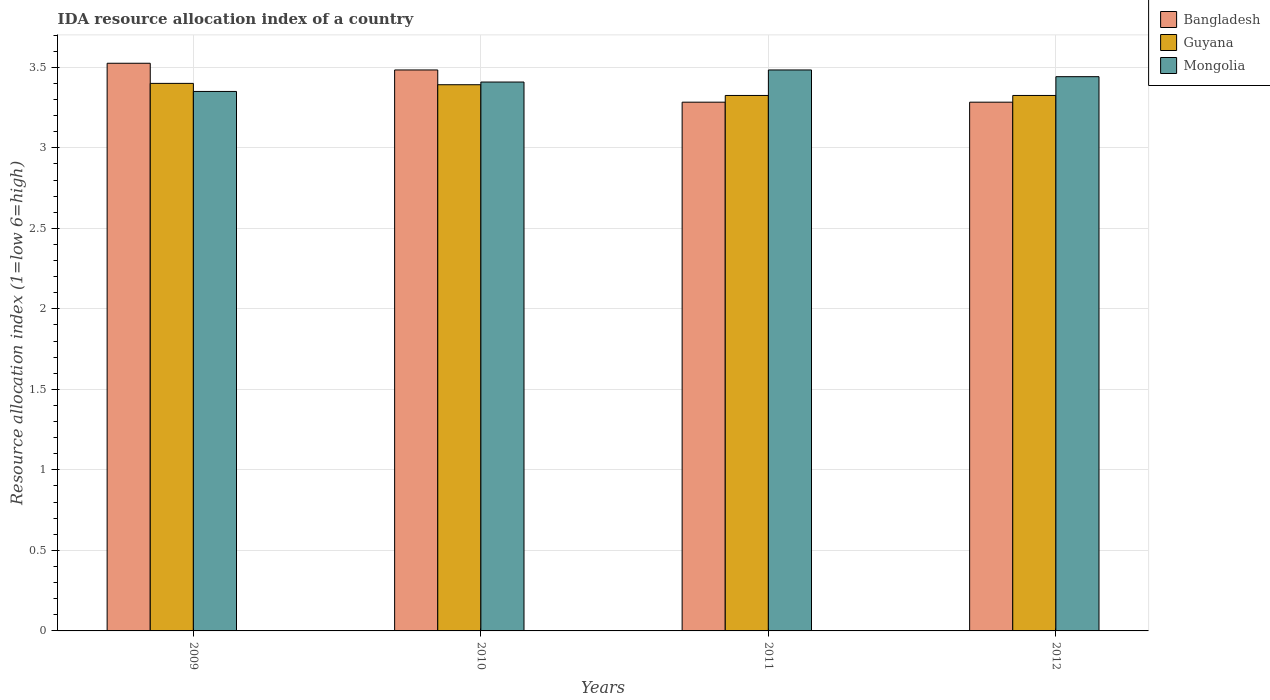Are the number of bars on each tick of the X-axis equal?
Your answer should be very brief. Yes. What is the IDA resource allocation index in Bangladesh in 2009?
Offer a very short reply. 3.52. Across all years, what is the maximum IDA resource allocation index in Bangladesh?
Offer a very short reply. 3.52. Across all years, what is the minimum IDA resource allocation index in Guyana?
Provide a succinct answer. 3.33. What is the total IDA resource allocation index in Bangladesh in the graph?
Keep it short and to the point. 13.57. What is the difference between the IDA resource allocation index in Bangladesh in 2009 and that in 2011?
Make the answer very short. 0.24. What is the difference between the IDA resource allocation index in Guyana in 2011 and the IDA resource allocation index in Bangladesh in 2009?
Make the answer very short. -0.2. What is the average IDA resource allocation index in Mongolia per year?
Keep it short and to the point. 3.42. In the year 2009, what is the difference between the IDA resource allocation index in Guyana and IDA resource allocation index in Mongolia?
Your answer should be very brief. 0.05. What is the ratio of the IDA resource allocation index in Mongolia in 2009 to that in 2012?
Your answer should be very brief. 0.97. Is the difference between the IDA resource allocation index in Guyana in 2009 and 2012 greater than the difference between the IDA resource allocation index in Mongolia in 2009 and 2012?
Your answer should be very brief. Yes. What is the difference between the highest and the second highest IDA resource allocation index in Guyana?
Your answer should be very brief. 0.01. What is the difference between the highest and the lowest IDA resource allocation index in Mongolia?
Offer a very short reply. 0.13. Is the sum of the IDA resource allocation index in Bangladesh in 2010 and 2011 greater than the maximum IDA resource allocation index in Mongolia across all years?
Ensure brevity in your answer.  Yes. What does the 3rd bar from the left in 2010 represents?
Offer a terse response. Mongolia. What does the 3rd bar from the right in 2010 represents?
Offer a very short reply. Bangladesh. How many bars are there?
Give a very brief answer. 12. How many years are there in the graph?
Give a very brief answer. 4. What is the difference between two consecutive major ticks on the Y-axis?
Your answer should be very brief. 0.5. Are the values on the major ticks of Y-axis written in scientific E-notation?
Ensure brevity in your answer.  No. Does the graph contain any zero values?
Keep it short and to the point. No. How many legend labels are there?
Offer a terse response. 3. How are the legend labels stacked?
Make the answer very short. Vertical. What is the title of the graph?
Your response must be concise. IDA resource allocation index of a country. Does "Low income" appear as one of the legend labels in the graph?
Provide a succinct answer. No. What is the label or title of the X-axis?
Your answer should be compact. Years. What is the label or title of the Y-axis?
Give a very brief answer. Resource allocation index (1=low 6=high). What is the Resource allocation index (1=low 6=high) of Bangladesh in 2009?
Provide a succinct answer. 3.52. What is the Resource allocation index (1=low 6=high) of Guyana in 2009?
Provide a succinct answer. 3.4. What is the Resource allocation index (1=low 6=high) in Mongolia in 2009?
Give a very brief answer. 3.35. What is the Resource allocation index (1=low 6=high) of Bangladesh in 2010?
Keep it short and to the point. 3.48. What is the Resource allocation index (1=low 6=high) in Guyana in 2010?
Offer a very short reply. 3.39. What is the Resource allocation index (1=low 6=high) of Mongolia in 2010?
Offer a terse response. 3.41. What is the Resource allocation index (1=low 6=high) in Bangladesh in 2011?
Offer a terse response. 3.28. What is the Resource allocation index (1=low 6=high) of Guyana in 2011?
Provide a short and direct response. 3.33. What is the Resource allocation index (1=low 6=high) in Mongolia in 2011?
Make the answer very short. 3.48. What is the Resource allocation index (1=low 6=high) of Bangladesh in 2012?
Offer a terse response. 3.28. What is the Resource allocation index (1=low 6=high) in Guyana in 2012?
Provide a short and direct response. 3.33. What is the Resource allocation index (1=low 6=high) of Mongolia in 2012?
Ensure brevity in your answer.  3.44. Across all years, what is the maximum Resource allocation index (1=low 6=high) in Bangladesh?
Ensure brevity in your answer.  3.52. Across all years, what is the maximum Resource allocation index (1=low 6=high) in Mongolia?
Keep it short and to the point. 3.48. Across all years, what is the minimum Resource allocation index (1=low 6=high) in Bangladesh?
Ensure brevity in your answer.  3.28. Across all years, what is the minimum Resource allocation index (1=low 6=high) of Guyana?
Your answer should be very brief. 3.33. Across all years, what is the minimum Resource allocation index (1=low 6=high) in Mongolia?
Ensure brevity in your answer.  3.35. What is the total Resource allocation index (1=low 6=high) in Bangladesh in the graph?
Your response must be concise. 13.57. What is the total Resource allocation index (1=low 6=high) in Guyana in the graph?
Offer a terse response. 13.44. What is the total Resource allocation index (1=low 6=high) in Mongolia in the graph?
Give a very brief answer. 13.68. What is the difference between the Resource allocation index (1=low 6=high) in Bangladesh in 2009 and that in 2010?
Make the answer very short. 0.04. What is the difference between the Resource allocation index (1=low 6=high) in Guyana in 2009 and that in 2010?
Offer a very short reply. 0.01. What is the difference between the Resource allocation index (1=low 6=high) of Mongolia in 2009 and that in 2010?
Keep it short and to the point. -0.06. What is the difference between the Resource allocation index (1=low 6=high) in Bangladesh in 2009 and that in 2011?
Give a very brief answer. 0.24. What is the difference between the Resource allocation index (1=low 6=high) of Guyana in 2009 and that in 2011?
Your answer should be very brief. 0.07. What is the difference between the Resource allocation index (1=low 6=high) in Mongolia in 2009 and that in 2011?
Provide a short and direct response. -0.13. What is the difference between the Resource allocation index (1=low 6=high) in Bangladesh in 2009 and that in 2012?
Give a very brief answer. 0.24. What is the difference between the Resource allocation index (1=low 6=high) of Guyana in 2009 and that in 2012?
Provide a succinct answer. 0.07. What is the difference between the Resource allocation index (1=low 6=high) of Mongolia in 2009 and that in 2012?
Your response must be concise. -0.09. What is the difference between the Resource allocation index (1=low 6=high) in Bangladesh in 2010 and that in 2011?
Your answer should be very brief. 0.2. What is the difference between the Resource allocation index (1=low 6=high) in Guyana in 2010 and that in 2011?
Provide a short and direct response. 0.07. What is the difference between the Resource allocation index (1=low 6=high) of Mongolia in 2010 and that in 2011?
Provide a short and direct response. -0.07. What is the difference between the Resource allocation index (1=low 6=high) of Guyana in 2010 and that in 2012?
Your answer should be compact. 0.07. What is the difference between the Resource allocation index (1=low 6=high) in Mongolia in 2010 and that in 2012?
Keep it short and to the point. -0.03. What is the difference between the Resource allocation index (1=low 6=high) in Bangladesh in 2011 and that in 2012?
Make the answer very short. 0. What is the difference between the Resource allocation index (1=low 6=high) of Guyana in 2011 and that in 2012?
Keep it short and to the point. 0. What is the difference between the Resource allocation index (1=low 6=high) of Mongolia in 2011 and that in 2012?
Ensure brevity in your answer.  0.04. What is the difference between the Resource allocation index (1=low 6=high) in Bangladesh in 2009 and the Resource allocation index (1=low 6=high) in Guyana in 2010?
Make the answer very short. 0.13. What is the difference between the Resource allocation index (1=low 6=high) of Bangladesh in 2009 and the Resource allocation index (1=low 6=high) of Mongolia in 2010?
Ensure brevity in your answer.  0.12. What is the difference between the Resource allocation index (1=low 6=high) in Guyana in 2009 and the Resource allocation index (1=low 6=high) in Mongolia in 2010?
Your answer should be compact. -0.01. What is the difference between the Resource allocation index (1=low 6=high) in Bangladesh in 2009 and the Resource allocation index (1=low 6=high) in Guyana in 2011?
Your response must be concise. 0.2. What is the difference between the Resource allocation index (1=low 6=high) in Bangladesh in 2009 and the Resource allocation index (1=low 6=high) in Mongolia in 2011?
Offer a very short reply. 0.04. What is the difference between the Resource allocation index (1=low 6=high) in Guyana in 2009 and the Resource allocation index (1=low 6=high) in Mongolia in 2011?
Give a very brief answer. -0.08. What is the difference between the Resource allocation index (1=low 6=high) of Bangladesh in 2009 and the Resource allocation index (1=low 6=high) of Guyana in 2012?
Provide a succinct answer. 0.2. What is the difference between the Resource allocation index (1=low 6=high) in Bangladesh in 2009 and the Resource allocation index (1=low 6=high) in Mongolia in 2012?
Ensure brevity in your answer.  0.08. What is the difference between the Resource allocation index (1=low 6=high) in Guyana in 2009 and the Resource allocation index (1=low 6=high) in Mongolia in 2012?
Provide a succinct answer. -0.04. What is the difference between the Resource allocation index (1=low 6=high) in Bangladesh in 2010 and the Resource allocation index (1=low 6=high) in Guyana in 2011?
Offer a terse response. 0.16. What is the difference between the Resource allocation index (1=low 6=high) in Bangladesh in 2010 and the Resource allocation index (1=low 6=high) in Mongolia in 2011?
Offer a very short reply. 0. What is the difference between the Resource allocation index (1=low 6=high) of Guyana in 2010 and the Resource allocation index (1=low 6=high) of Mongolia in 2011?
Your answer should be compact. -0.09. What is the difference between the Resource allocation index (1=low 6=high) in Bangladesh in 2010 and the Resource allocation index (1=low 6=high) in Guyana in 2012?
Your answer should be very brief. 0.16. What is the difference between the Resource allocation index (1=low 6=high) in Bangladesh in 2010 and the Resource allocation index (1=low 6=high) in Mongolia in 2012?
Offer a very short reply. 0.04. What is the difference between the Resource allocation index (1=low 6=high) of Bangladesh in 2011 and the Resource allocation index (1=low 6=high) of Guyana in 2012?
Your response must be concise. -0.04. What is the difference between the Resource allocation index (1=low 6=high) in Bangladesh in 2011 and the Resource allocation index (1=low 6=high) in Mongolia in 2012?
Provide a succinct answer. -0.16. What is the difference between the Resource allocation index (1=low 6=high) in Guyana in 2011 and the Resource allocation index (1=low 6=high) in Mongolia in 2012?
Give a very brief answer. -0.12. What is the average Resource allocation index (1=low 6=high) of Bangladesh per year?
Give a very brief answer. 3.39. What is the average Resource allocation index (1=low 6=high) of Guyana per year?
Ensure brevity in your answer.  3.36. What is the average Resource allocation index (1=low 6=high) in Mongolia per year?
Your response must be concise. 3.42. In the year 2009, what is the difference between the Resource allocation index (1=low 6=high) in Bangladesh and Resource allocation index (1=low 6=high) in Guyana?
Provide a short and direct response. 0.12. In the year 2009, what is the difference between the Resource allocation index (1=low 6=high) of Bangladesh and Resource allocation index (1=low 6=high) of Mongolia?
Provide a short and direct response. 0.17. In the year 2009, what is the difference between the Resource allocation index (1=low 6=high) in Guyana and Resource allocation index (1=low 6=high) in Mongolia?
Provide a short and direct response. 0.05. In the year 2010, what is the difference between the Resource allocation index (1=low 6=high) in Bangladesh and Resource allocation index (1=low 6=high) in Guyana?
Your response must be concise. 0.09. In the year 2010, what is the difference between the Resource allocation index (1=low 6=high) in Bangladesh and Resource allocation index (1=low 6=high) in Mongolia?
Your response must be concise. 0.07. In the year 2010, what is the difference between the Resource allocation index (1=low 6=high) in Guyana and Resource allocation index (1=low 6=high) in Mongolia?
Offer a terse response. -0.02. In the year 2011, what is the difference between the Resource allocation index (1=low 6=high) in Bangladesh and Resource allocation index (1=low 6=high) in Guyana?
Your answer should be very brief. -0.04. In the year 2011, what is the difference between the Resource allocation index (1=low 6=high) of Bangladesh and Resource allocation index (1=low 6=high) of Mongolia?
Provide a short and direct response. -0.2. In the year 2011, what is the difference between the Resource allocation index (1=low 6=high) of Guyana and Resource allocation index (1=low 6=high) of Mongolia?
Offer a terse response. -0.16. In the year 2012, what is the difference between the Resource allocation index (1=low 6=high) of Bangladesh and Resource allocation index (1=low 6=high) of Guyana?
Your response must be concise. -0.04. In the year 2012, what is the difference between the Resource allocation index (1=low 6=high) in Bangladesh and Resource allocation index (1=low 6=high) in Mongolia?
Your answer should be compact. -0.16. In the year 2012, what is the difference between the Resource allocation index (1=low 6=high) in Guyana and Resource allocation index (1=low 6=high) in Mongolia?
Make the answer very short. -0.12. What is the ratio of the Resource allocation index (1=low 6=high) of Bangladesh in 2009 to that in 2010?
Ensure brevity in your answer.  1.01. What is the ratio of the Resource allocation index (1=low 6=high) of Guyana in 2009 to that in 2010?
Your answer should be very brief. 1. What is the ratio of the Resource allocation index (1=low 6=high) of Mongolia in 2009 to that in 2010?
Your answer should be compact. 0.98. What is the ratio of the Resource allocation index (1=low 6=high) in Bangladesh in 2009 to that in 2011?
Keep it short and to the point. 1.07. What is the ratio of the Resource allocation index (1=low 6=high) of Guyana in 2009 to that in 2011?
Make the answer very short. 1.02. What is the ratio of the Resource allocation index (1=low 6=high) of Mongolia in 2009 to that in 2011?
Provide a short and direct response. 0.96. What is the ratio of the Resource allocation index (1=low 6=high) of Bangladesh in 2009 to that in 2012?
Ensure brevity in your answer.  1.07. What is the ratio of the Resource allocation index (1=low 6=high) in Guyana in 2009 to that in 2012?
Keep it short and to the point. 1.02. What is the ratio of the Resource allocation index (1=low 6=high) of Mongolia in 2009 to that in 2012?
Offer a terse response. 0.97. What is the ratio of the Resource allocation index (1=low 6=high) in Bangladesh in 2010 to that in 2011?
Keep it short and to the point. 1.06. What is the ratio of the Resource allocation index (1=low 6=high) in Guyana in 2010 to that in 2011?
Offer a terse response. 1.02. What is the ratio of the Resource allocation index (1=low 6=high) in Mongolia in 2010 to that in 2011?
Provide a succinct answer. 0.98. What is the ratio of the Resource allocation index (1=low 6=high) of Bangladesh in 2010 to that in 2012?
Ensure brevity in your answer.  1.06. What is the ratio of the Resource allocation index (1=low 6=high) of Guyana in 2010 to that in 2012?
Provide a succinct answer. 1.02. What is the ratio of the Resource allocation index (1=low 6=high) of Mongolia in 2010 to that in 2012?
Your response must be concise. 0.99. What is the ratio of the Resource allocation index (1=low 6=high) of Mongolia in 2011 to that in 2012?
Ensure brevity in your answer.  1.01. What is the difference between the highest and the second highest Resource allocation index (1=low 6=high) of Bangladesh?
Offer a terse response. 0.04. What is the difference between the highest and the second highest Resource allocation index (1=low 6=high) of Guyana?
Ensure brevity in your answer.  0.01. What is the difference between the highest and the second highest Resource allocation index (1=low 6=high) of Mongolia?
Give a very brief answer. 0.04. What is the difference between the highest and the lowest Resource allocation index (1=low 6=high) of Bangladesh?
Your answer should be compact. 0.24. What is the difference between the highest and the lowest Resource allocation index (1=low 6=high) in Guyana?
Offer a very short reply. 0.07. What is the difference between the highest and the lowest Resource allocation index (1=low 6=high) in Mongolia?
Provide a short and direct response. 0.13. 